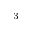<formula> <loc_0><loc_0><loc_500><loc_500>^ { 3 }</formula> 